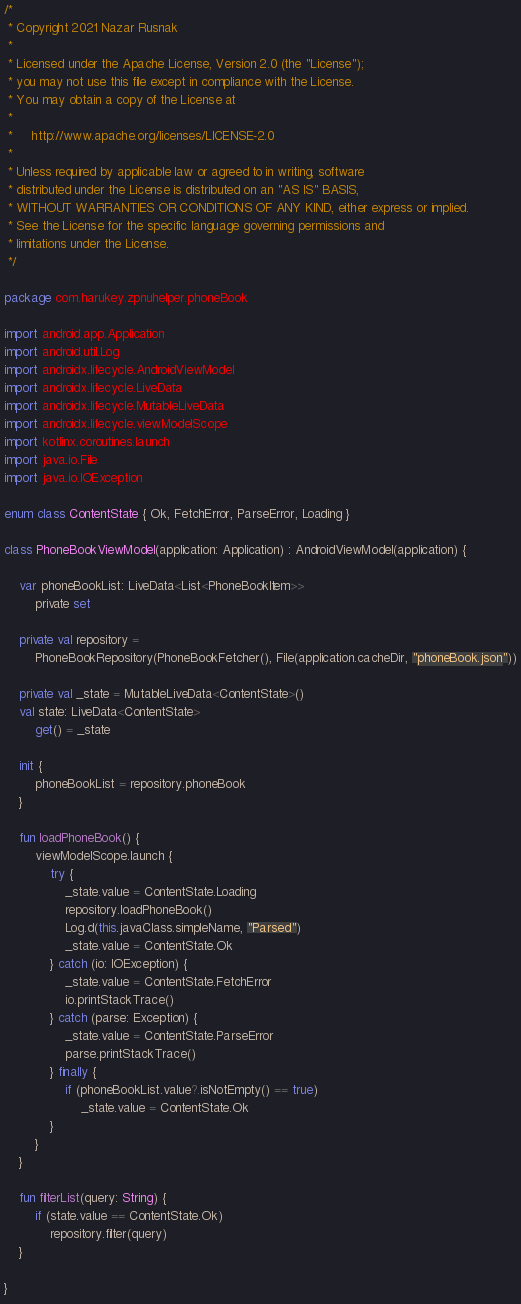Convert code to text. <code><loc_0><loc_0><loc_500><loc_500><_Kotlin_>/*
 * Copyright 2021 Nazar Rusnak
 *
 * Licensed under the Apache License, Version 2.0 (the "License");
 * you may not use this file except in compliance with the License.
 * You may obtain a copy of the License at
 *
 *     http://www.apache.org/licenses/LICENSE-2.0
 *
 * Unless required by applicable law or agreed to in writing, software
 * distributed under the License is distributed on an "AS IS" BASIS,
 * WITHOUT WARRANTIES OR CONDITIONS OF ANY KIND, either express or implied.
 * See the License for the specific language governing permissions and
 * limitations under the License.
 */

package com.harukey.zpnuhelper.phoneBook

import android.app.Application
import android.util.Log
import androidx.lifecycle.AndroidViewModel
import androidx.lifecycle.LiveData
import androidx.lifecycle.MutableLiveData
import androidx.lifecycle.viewModelScope
import kotlinx.coroutines.launch
import java.io.File
import java.io.IOException

enum class ContentState { Ok, FetchError, ParseError, Loading }

class PhoneBookViewModel(application: Application) : AndroidViewModel(application) {

    var phoneBookList: LiveData<List<PhoneBookItem>>
        private set

    private val repository =
        PhoneBookRepository(PhoneBookFetcher(), File(application.cacheDir, "phoneBook.json"))

    private val _state = MutableLiveData<ContentState>()
    val state: LiveData<ContentState>
        get() = _state

    init {
        phoneBookList = repository.phoneBook
    }

    fun loadPhoneBook() {
        viewModelScope.launch {
            try {
                _state.value = ContentState.Loading
                repository.loadPhoneBook()
                Log.d(this.javaClass.simpleName, "Parsed")
                _state.value = ContentState.Ok
            } catch (io: IOException) {
                _state.value = ContentState.FetchError
                io.printStackTrace()
            } catch (parse: Exception) {
                _state.value = ContentState.ParseError
                parse.printStackTrace()
            } finally {
                if (phoneBookList.value?.isNotEmpty() == true)
                    _state.value = ContentState.Ok
            }
        }
    }

    fun filterList(query: String) {
        if (state.value == ContentState.Ok)
            repository.filter(query)
    }

}</code> 